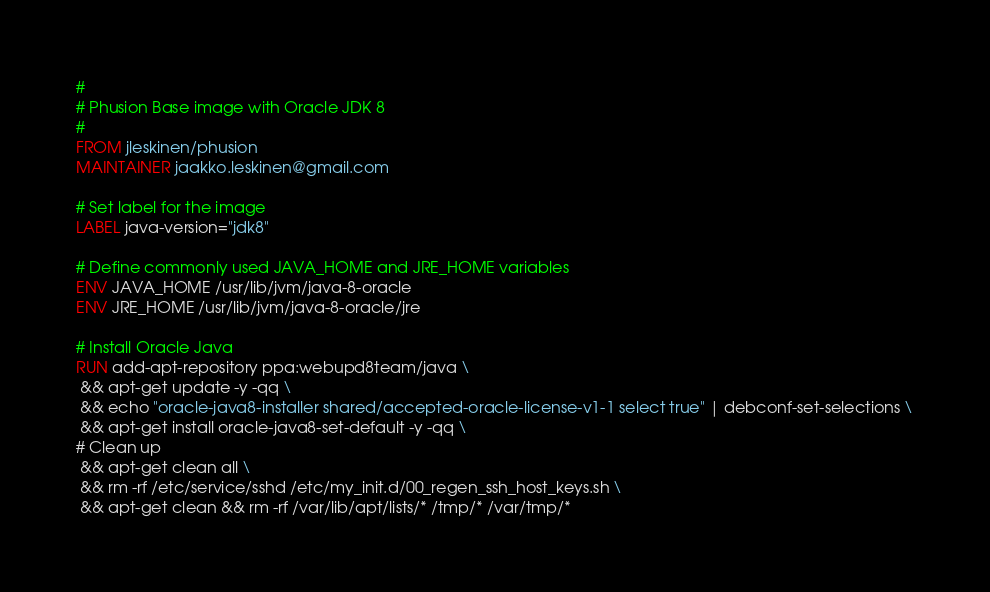<code> <loc_0><loc_0><loc_500><loc_500><_Dockerfile_>#
# Phusion Base image with Oracle JDK 8
#
FROM jleskinen/phusion
MAINTAINER jaakko.leskinen@gmail.com

# Set label for the image
LABEL java-version="jdk8"

# Define commonly used JAVA_HOME and JRE_HOME variables
ENV JAVA_HOME /usr/lib/jvm/java-8-oracle
ENV JRE_HOME /usr/lib/jvm/java-8-oracle/jre

# Install Oracle Java
RUN add-apt-repository ppa:webupd8team/java \
 && apt-get update -y -qq \
 && echo "oracle-java8-installer shared/accepted-oracle-license-v1-1 select true" | debconf-set-selections \
 && apt-get install oracle-java8-set-default -y -qq \
# Clean up
 && apt-get clean all \
 && rm -rf /etc/service/sshd /etc/my_init.d/00_regen_ssh_host_keys.sh \
 && apt-get clean && rm -rf /var/lib/apt/lists/* /tmp/* /var/tmp/*</code> 